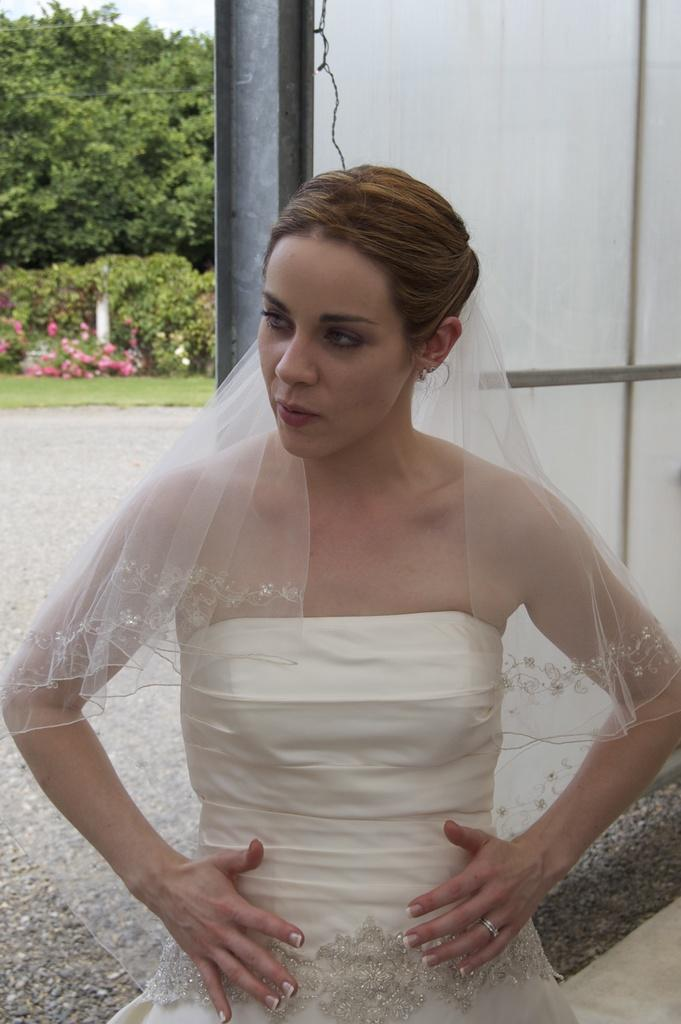Who is the main subject in the image? There is a woman standing in the middle of the image. What can be seen in the background of the image? There is a pole, green color plants, and trees in the background of the image. What type of degree is the woman holding in the image? There is no degree visible in the image; the woman is simply standing. How many chairs can be seen in the image? There are no chairs present in the image. 